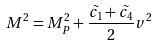Convert formula to latex. <formula><loc_0><loc_0><loc_500><loc_500>M ^ { 2 } = M _ { P } ^ { 2 } + \frac { \tilde { c _ { 1 } } + \tilde { c _ { 4 } } } { 2 } v ^ { 2 }</formula> 